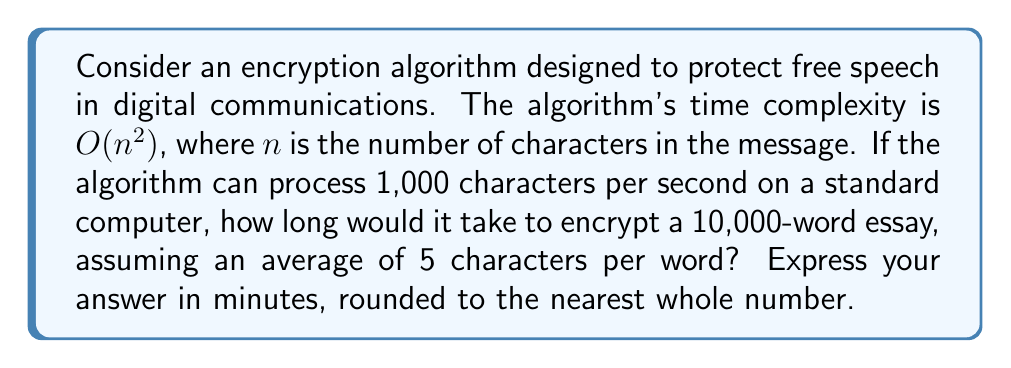Teach me how to tackle this problem. To solve this problem, we need to follow these steps:

1. Calculate the total number of characters in the essay:
   - Number of words = 10,000
   - Average characters per word = 5
   - Total characters = $10,000 \times 5 = 50,000$ characters

2. Determine the time complexity for 50,000 characters:
   - The algorithm's time complexity is $O(n^2)$
   - For 50,000 characters, the time would be proportional to $50,000^2 = 2,500,000,000$

3. Calculate the actual time based on the given processing speed:
   - The algorithm can process 1,000 characters per second
   - Time for 50,000 characters = $\frac{2,500,000,000}{1,000} = 2,500,000$ seconds

4. Convert seconds to minutes:
   - $2,500,000$ seconds = $\frac{2,500,000}{60} = 41,666.67$ minutes

5. Round to the nearest whole number:
   - 41,666.67 rounds to 41,667 minutes

This calculation shows that the encryption algorithm would take a significant amount of time to process a 10,000-word essay, which could be seen as a potential infringement on the freedom of speech due to the delay in communication. This inefficiency might be used as an argument against implementing such regulations.
Answer: 41,667 minutes 